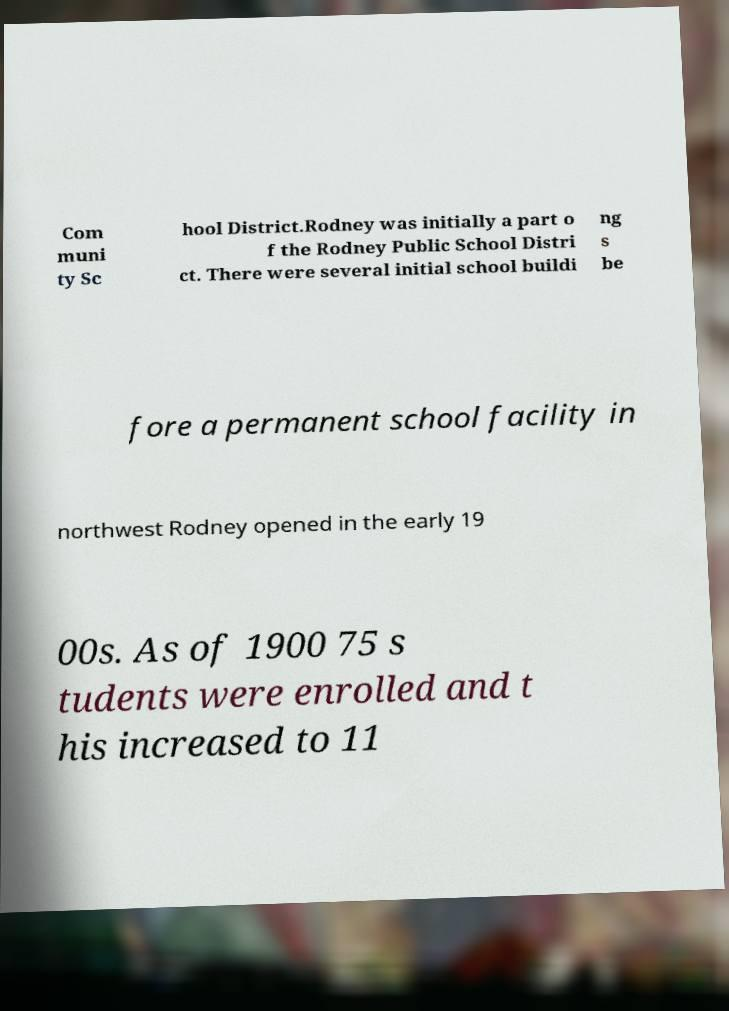Can you accurately transcribe the text from the provided image for me? Com muni ty Sc hool District.Rodney was initially a part o f the Rodney Public School Distri ct. There were several initial school buildi ng s be fore a permanent school facility in northwest Rodney opened in the early 19 00s. As of 1900 75 s tudents were enrolled and t his increased to 11 